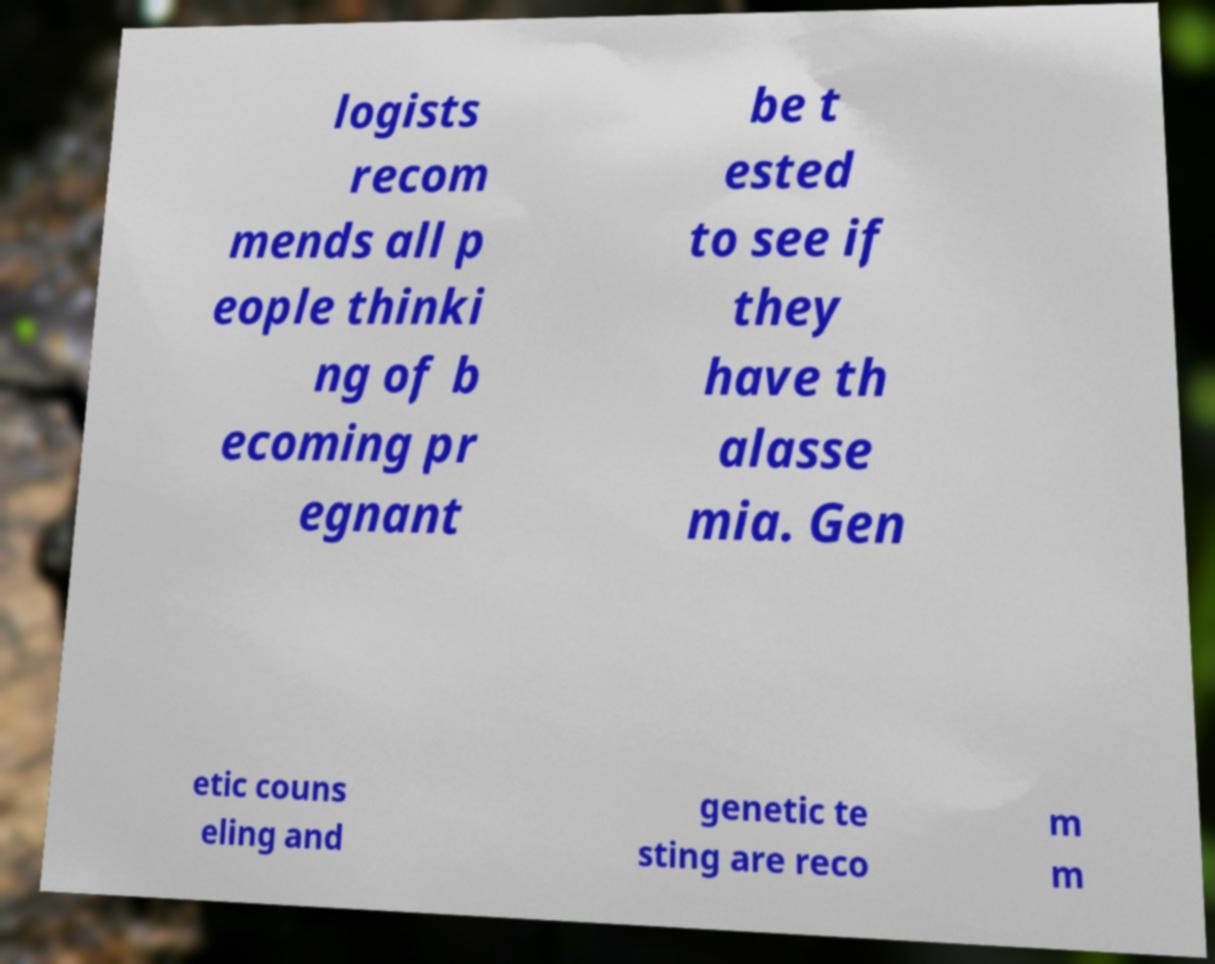Could you assist in decoding the text presented in this image and type it out clearly? logists recom mends all p eople thinki ng of b ecoming pr egnant be t ested to see if they have th alasse mia. Gen etic couns eling and genetic te sting are reco m m 